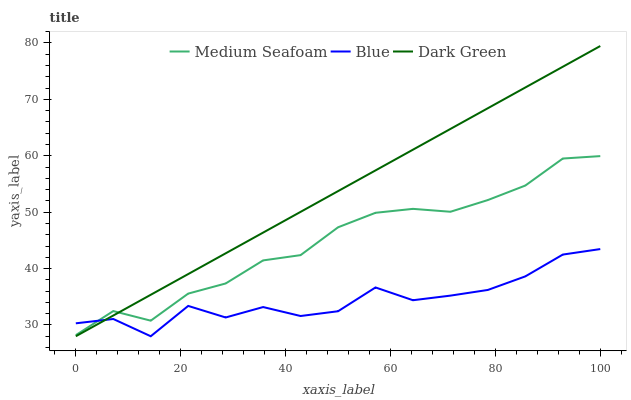Does Blue have the minimum area under the curve?
Answer yes or no. Yes. Does Dark Green have the maximum area under the curve?
Answer yes or no. Yes. Does Medium Seafoam have the minimum area under the curve?
Answer yes or no. No. Does Medium Seafoam have the maximum area under the curve?
Answer yes or no. No. Is Dark Green the smoothest?
Answer yes or no. Yes. Is Blue the roughest?
Answer yes or no. Yes. Is Medium Seafoam the smoothest?
Answer yes or no. No. Is Medium Seafoam the roughest?
Answer yes or no. No. Does Blue have the lowest value?
Answer yes or no. Yes. Does Medium Seafoam have the lowest value?
Answer yes or no. No. Does Dark Green have the highest value?
Answer yes or no. Yes. Does Medium Seafoam have the highest value?
Answer yes or no. No. Does Blue intersect Medium Seafoam?
Answer yes or no. Yes. Is Blue less than Medium Seafoam?
Answer yes or no. No. Is Blue greater than Medium Seafoam?
Answer yes or no. No. 